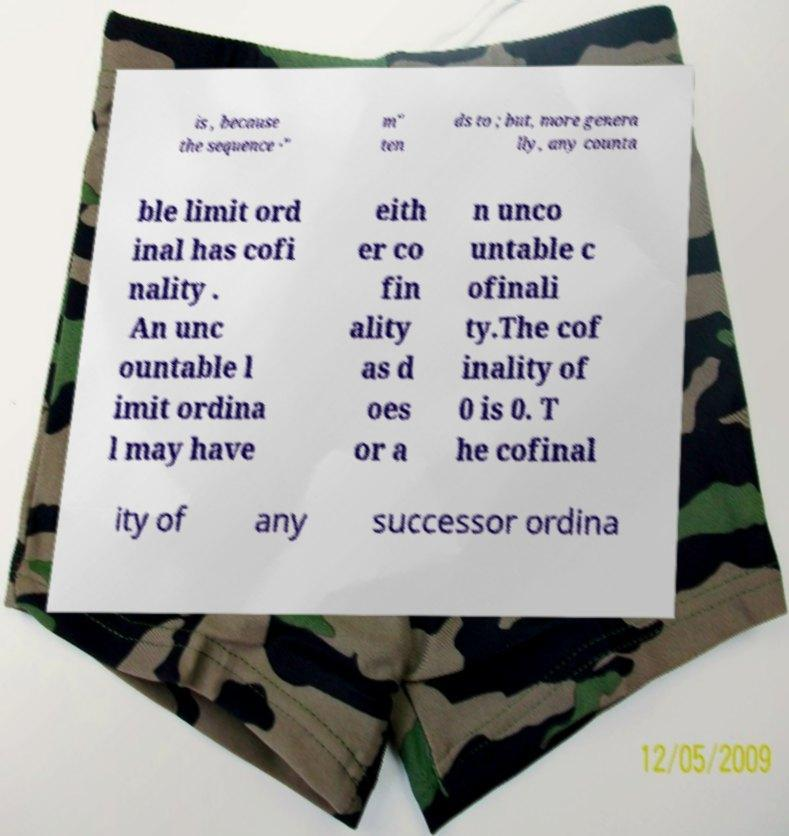What messages or text are displayed in this image? I need them in a readable, typed format. is , because the sequence ·" m" ten ds to ; but, more genera lly, any counta ble limit ord inal has cofi nality . An unc ountable l imit ordina l may have eith er co fin ality as d oes or a n unco untable c ofinali ty.The cof inality of 0 is 0. T he cofinal ity of any successor ordina 